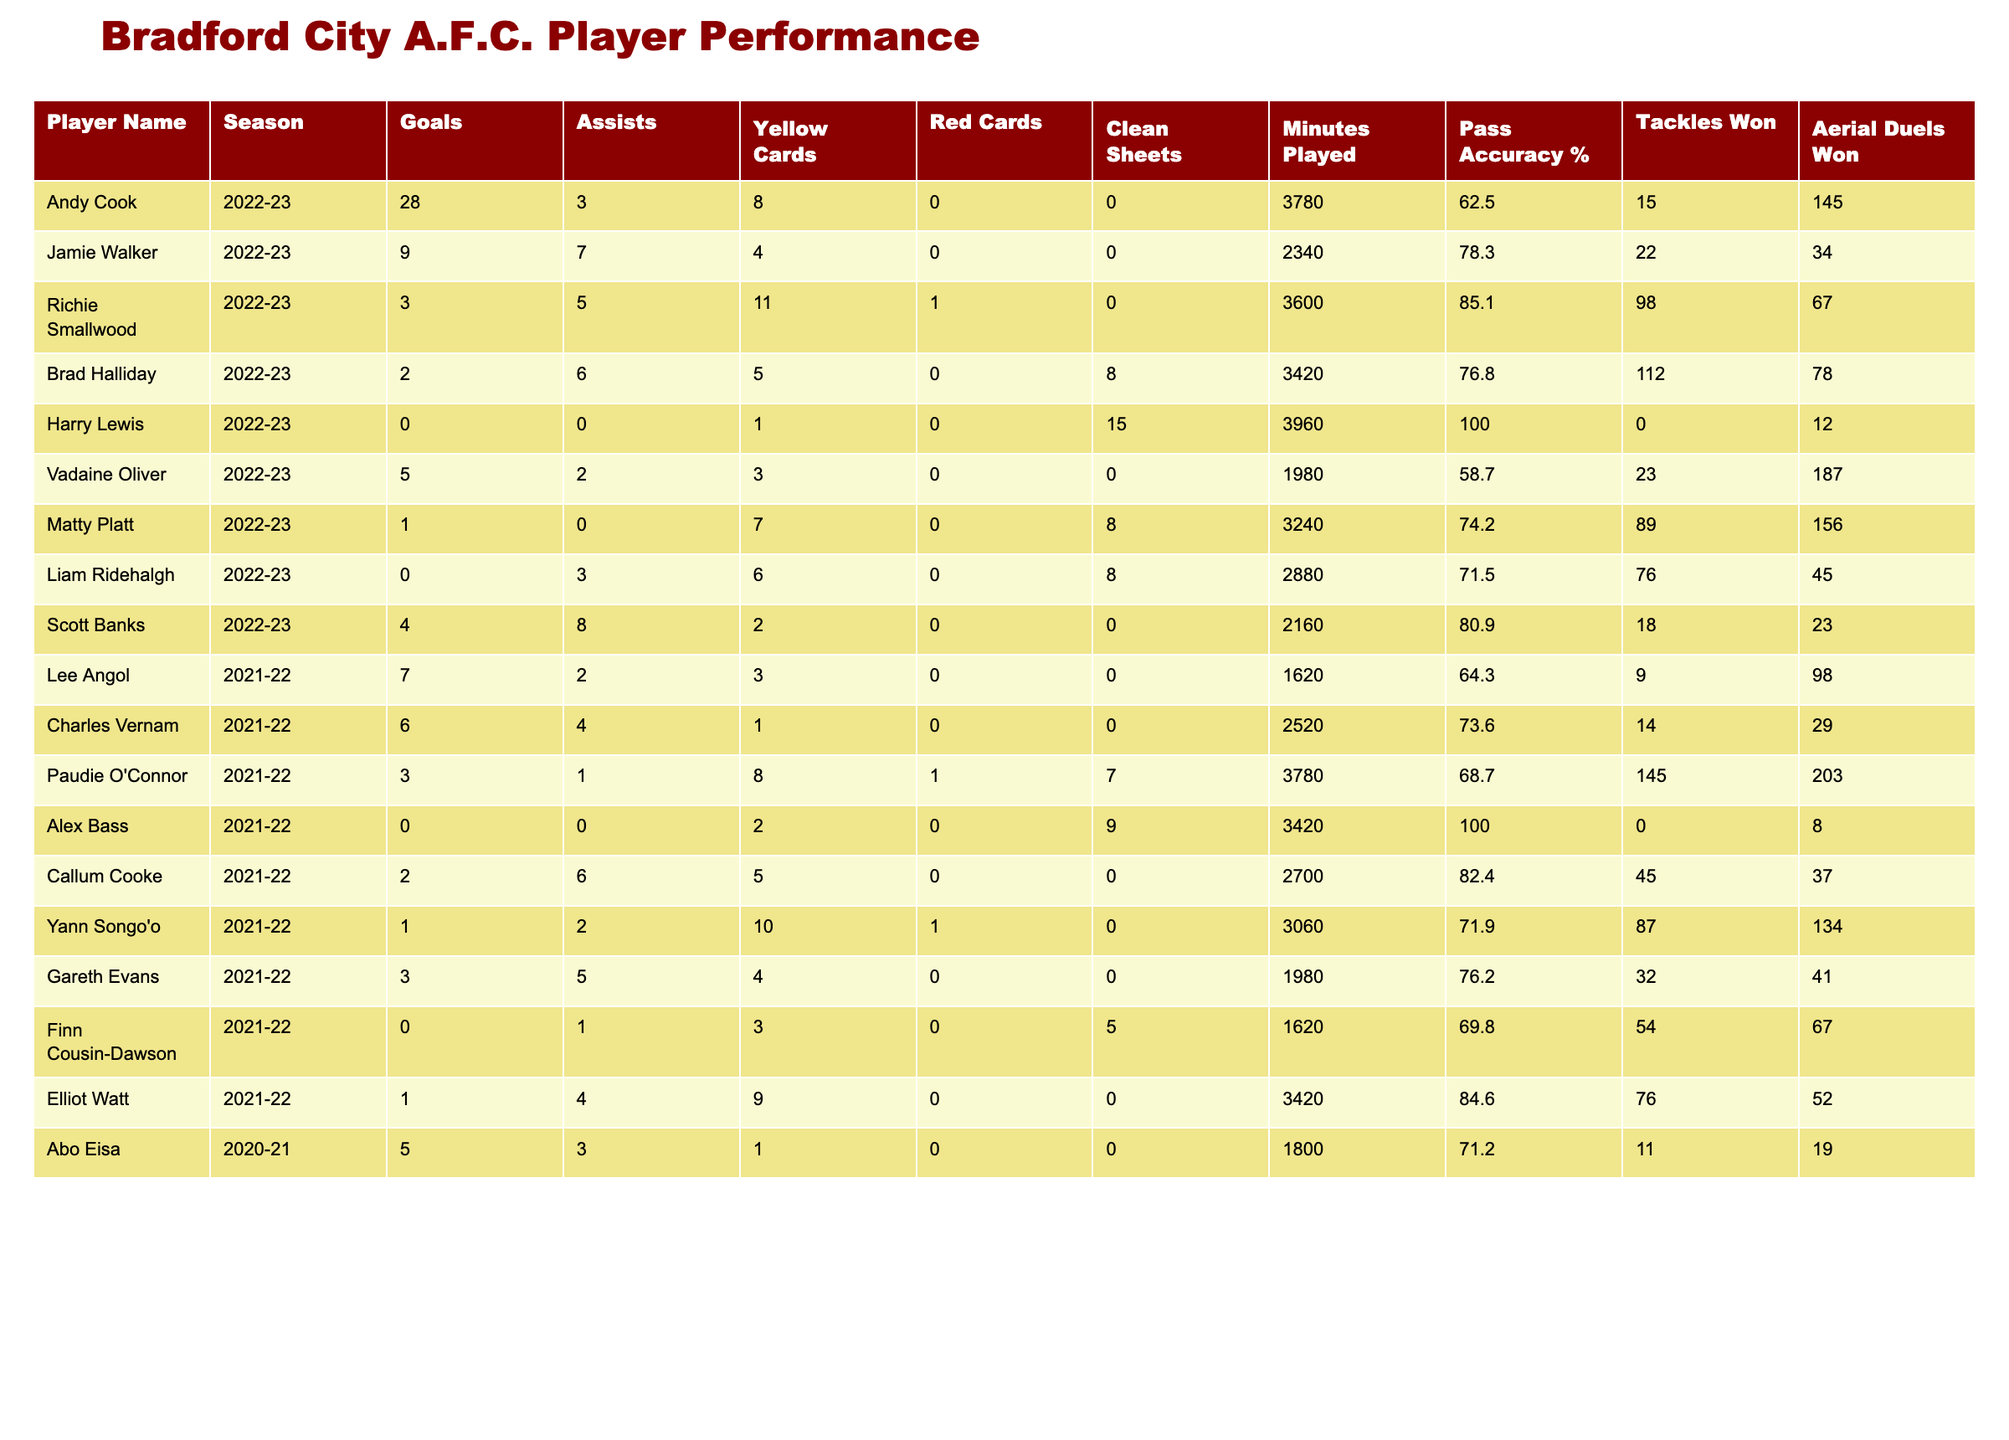What was Andy Cook's total contributions in terms of goals and assists for the 2022-23 season? Andy Cook scored 28 goals and provided 3 assists. When we sum these figures, we get a total of 31 contributions (28 + 3).
Answer: 31 Which player had the highest pass accuracy in the 2022-23 season? From the table, the player with the highest pass accuracy in the 2022-23 season is Harry Lewis, with a pass accuracy of 100%.
Answer: Harry Lewis How many clean sheets did Richie Smallwood record in the 2022-23 season? The table indicates that Richie Smallwood recorded 0 clean sheets in the 2022-23 season.
Answer: 0 Which player scored the fewest goals in the 2021-22 season? Looking at the goals scored in the 2021-22 season, both Alex Bass and Yann Songo'o scored the fewest with 0 and 1 goal respectively. Hence, Alex Bass is the one with the absolute fewest.
Answer: Alex Bass If we consider the total goals scored by players for the 2022-23 season, what is the average number of goals scored per player in that season? In the 2022-23 season, the total goals scored by players are 28 (Andy Cook) + 9 (Jamie Walker) + 3 (Richie Smallwood) + 2 (Brad Halliday) + 0 (Harry Lewis) + 5 (Vadaine Oliver) + 1 (Matty Platt) + 0 (Liam Ridehalgh) + 4 (Scott Banks) = 52 goals. There are 8 players who played, so the average is 52 / 8 = 6.5.
Answer: 6.5 Did any player receive more than 10 yellow cards during the 2022-23 season? The table shows that Richie Smallwood received 11 yellow cards, confirming that he did indeed receive more than 10 yellow cards.
Answer: Yes Considering all players in the table, who had the most minutes played in total, and how many minutes did they play? By checking the minutes played in the table, Harry Lewis has the most with 3960 minutes in the 2022-23 season.
Answer: Harry Lewis, 3960 minutes What is the difference in goals scored between the highest-scoring player in the 2022-23 season and the second highest? The highest-scoring player, Andy Cook, scored 28 goals, while the second highest was Jamie Walker with 9. The difference is 28 - 9 = 19.
Answer: 19 Which player had the best disciplinary record in terms of yellow and red cards combined during the 2021-22 season? Analyzing the disciplinary records for 2021-22, Yann Songo'o had the fewest combined with 10 total (10 yellow cards), while others had higher sums, making him the one with the best record.
Answer: Yann Songo'o What is the average pass accuracy of players listed in the table for the 2021-22 season? The pass accuracy for that season is: 64.3 (Lee Angol) + 73.6 (Charles Vernam) + 68.7 (Paudie O'Connor) + 100 (Alex Bass) + 82.4 (Callum Cooke) + 71.9 (Yann Songo'o) + 76.2 (Gareth Evans) + 69.8 (Finn Cousin-Dawson) + 84.6 (Elliot Watt) = 848. The total number of players is 9, so the average is 848 / 9 = 94.2.
Answer: 94.2 Which season featured the player with the most assists, and how many assists did they provide? Jamie Walker had the highest assists in the 2022-23 season with 7 assists. Therefore, the season with the most assists is 2022-23, with 7 assists.
Answer: 2022-23, 7 assists 